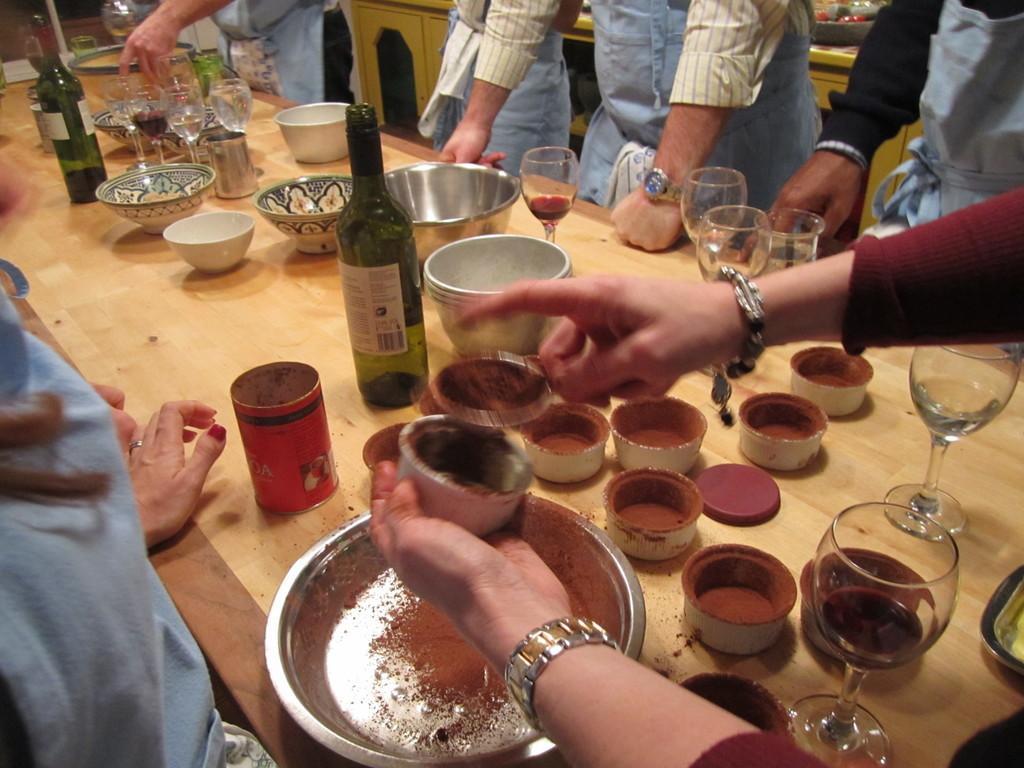Can you describe this image briefly? In this picture we can see a group of people standing and in front of them on the table we can see glasses, bottles, bowls and in the background we can see cupboards. 